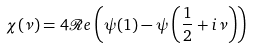<formula> <loc_0><loc_0><loc_500><loc_500>\chi ( \nu ) = 4 \mathcal { R } e \left ( \psi ( 1 ) - \psi \left ( \frac { 1 } { 2 } + i \nu \right ) \right )</formula> 